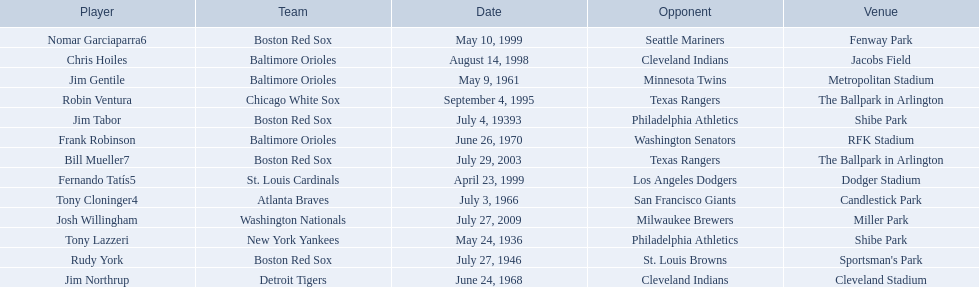What are the dates? May 24, 1936, July 4, 19393, July 27, 1946, May 9, 1961, July 3, 1966, June 24, 1968, June 26, 1970, September 4, 1995, August 14, 1998, April 23, 1999, May 10, 1999, July 29, 2003, July 27, 2009. Which date is in 1936? May 24, 1936. What player is listed for this date? Tony Lazzeri. 